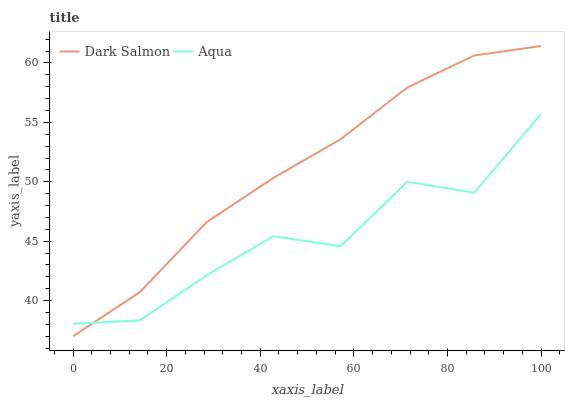Does Dark Salmon have the minimum area under the curve?
Answer yes or no. No. Is Dark Salmon the roughest?
Answer yes or no. No. 